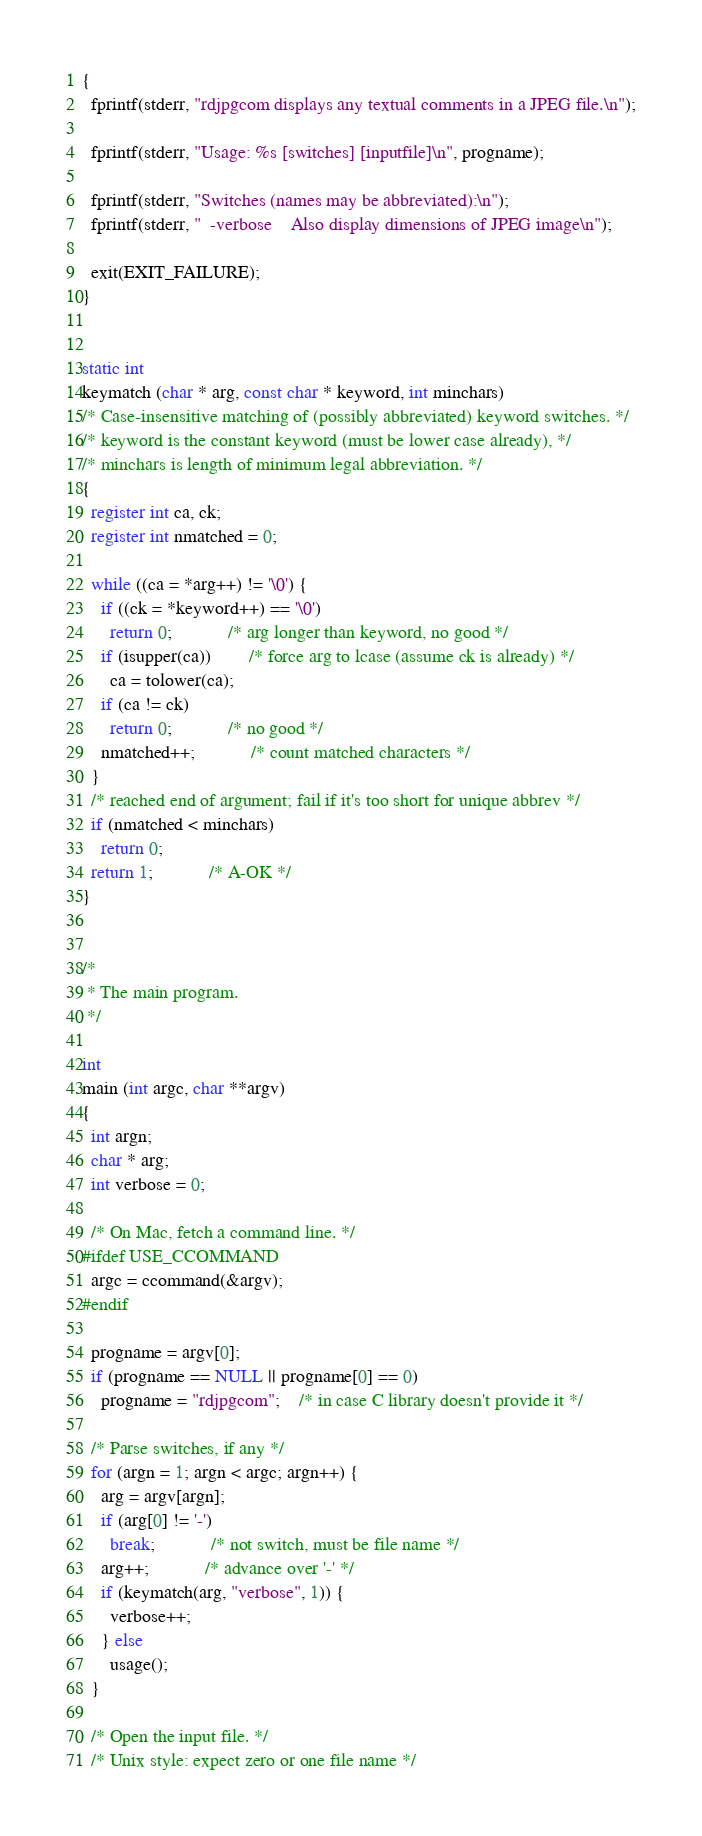<code> <loc_0><loc_0><loc_500><loc_500><_C_>{
  fprintf(stderr, "rdjpgcom displays any textual comments in a JPEG file.\n");

  fprintf(stderr, "Usage: %s [switches] [inputfile]\n", progname);

  fprintf(stderr, "Switches (names may be abbreviated):\n");
  fprintf(stderr, "  -verbose    Also display dimensions of JPEG image\n");

  exit(EXIT_FAILURE);
}


static int
keymatch (char * arg, const char * keyword, int minchars)
/* Case-insensitive matching of (possibly abbreviated) keyword switches. */
/* keyword is the constant keyword (must be lower case already), */
/* minchars is length of minimum legal abbreviation. */
{
  register int ca, ck;
  register int nmatched = 0;

  while ((ca = *arg++) != '\0') {
    if ((ck = *keyword++) == '\0')
      return 0;			/* arg longer than keyword, no good */
    if (isupper(ca))		/* force arg to lcase (assume ck is already) */
      ca = tolower(ca);
    if (ca != ck)
      return 0;			/* no good */
    nmatched++;			/* count matched characters */
  }
  /* reached end of argument; fail if it's too short for unique abbrev */
  if (nmatched < minchars)
    return 0;
  return 1;			/* A-OK */
}


/*
 * The main program.
 */

int
main (int argc, char **argv)
{
  int argn;
  char * arg;
  int verbose = 0;

  /* On Mac, fetch a command line. */
#ifdef USE_CCOMMAND
  argc = ccommand(&argv);
#endif

  progname = argv[0];
  if (progname == NULL || progname[0] == 0)
    progname = "rdjpgcom";	/* in case C library doesn't provide it */

  /* Parse switches, if any */
  for (argn = 1; argn < argc; argn++) {
    arg = argv[argn];
    if (arg[0] != '-')
      break;			/* not switch, must be file name */
    arg++;			/* advance over '-' */
    if (keymatch(arg, "verbose", 1)) {
      verbose++;
    } else
      usage();
  }

  /* Open the input file. */
  /* Unix style: expect zero or one file name */</code> 